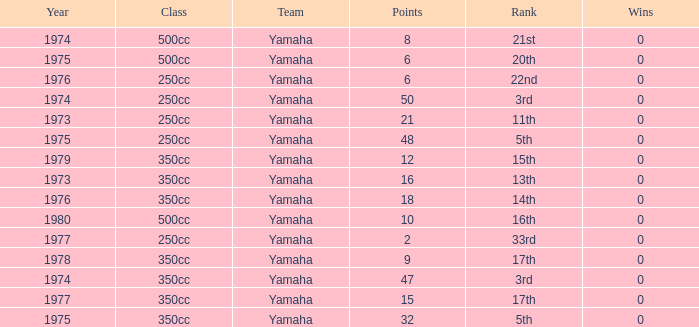Which Points is the lowest one that has a Year larger than 1974, and a Rank of 15th? 12.0. 